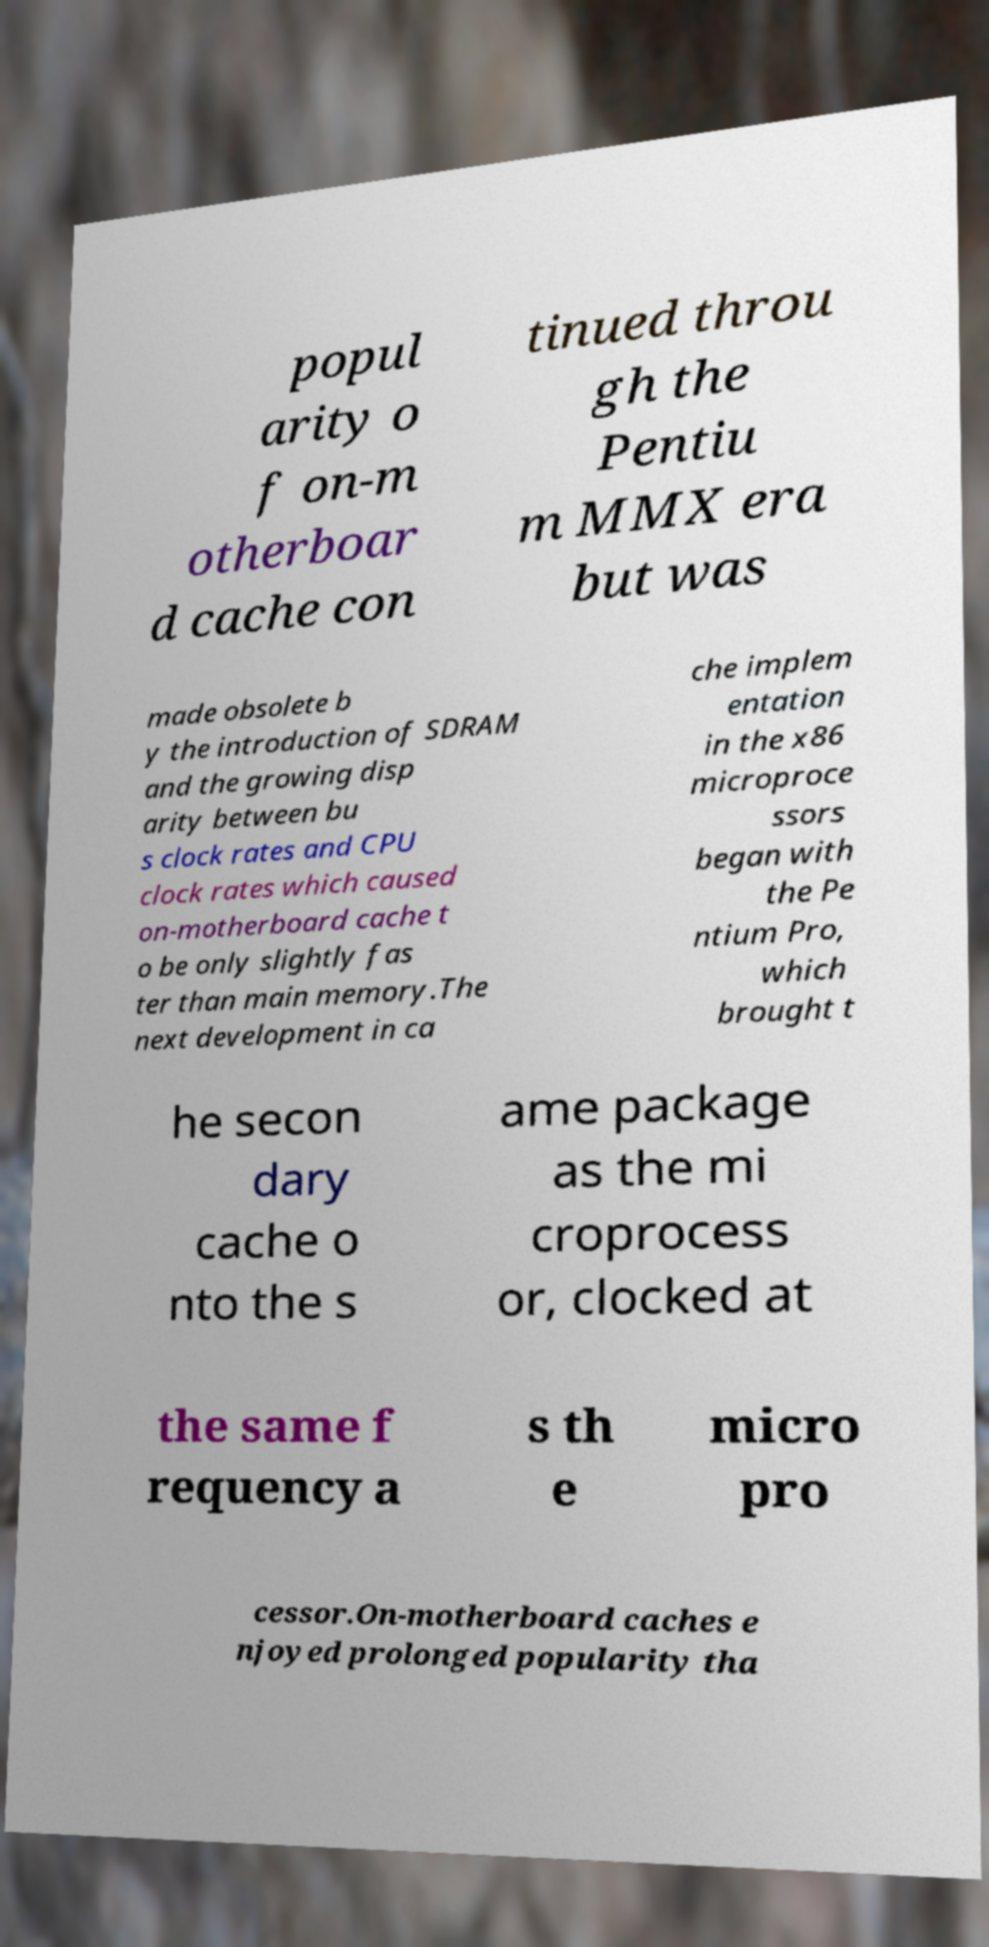Could you extract and type out the text from this image? popul arity o f on-m otherboar d cache con tinued throu gh the Pentiu m MMX era but was made obsolete b y the introduction of SDRAM and the growing disp arity between bu s clock rates and CPU clock rates which caused on-motherboard cache t o be only slightly fas ter than main memory.The next development in ca che implem entation in the x86 microproce ssors began with the Pe ntium Pro, which brought t he secon dary cache o nto the s ame package as the mi croprocess or, clocked at the same f requency a s th e micro pro cessor.On-motherboard caches e njoyed prolonged popularity tha 